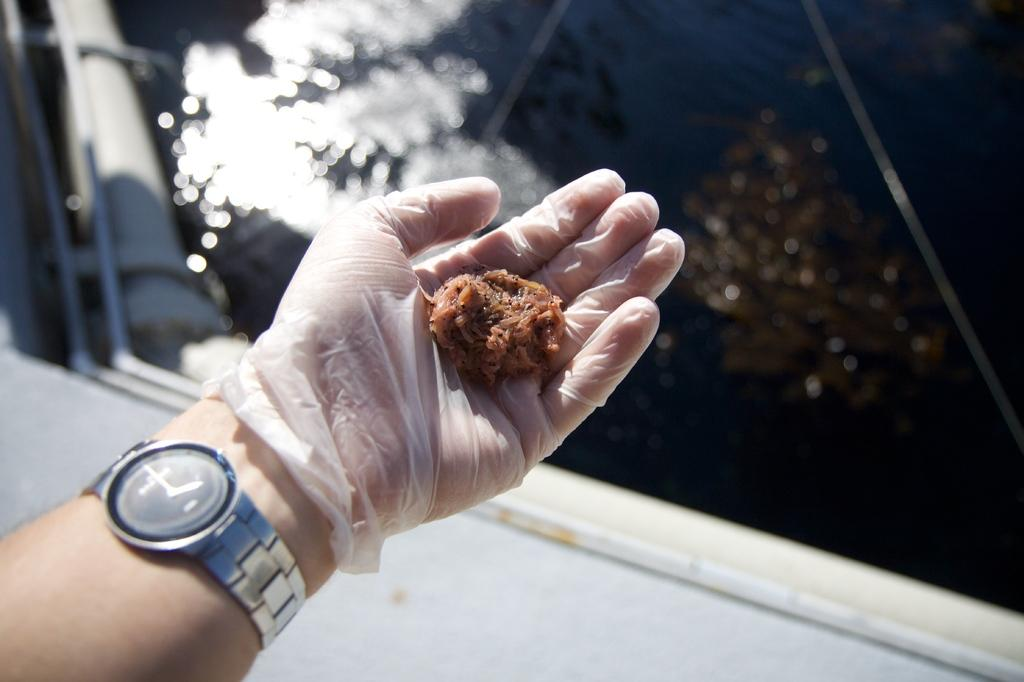What part of a person's body is visible in the image? There is a person's hand in the image. What is the hand wearing? The hand is wearing a watch and a glove. Can you describe the item on the glove? There is an item on the glove, but the specifics are not mentioned in the facts. What is located behind the hand? There is an object behind the hand. What natural element can be seen in the image? Water is visible in the image. What month is it in the image? The facts provided do not mention any information about the month, so it cannot be determined from the image. Can you tell me how many cows are in the image? There are no cows present in the image. 